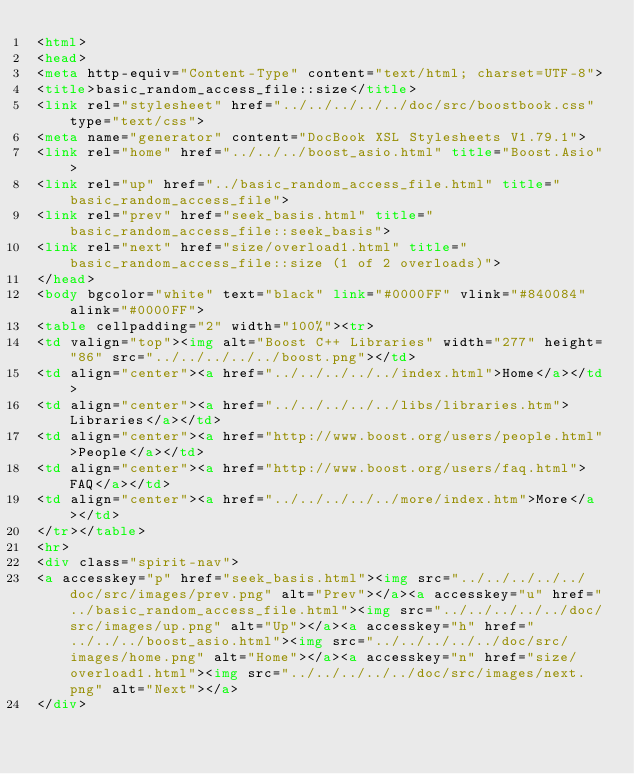<code> <loc_0><loc_0><loc_500><loc_500><_HTML_><html>
<head>
<meta http-equiv="Content-Type" content="text/html; charset=UTF-8">
<title>basic_random_access_file::size</title>
<link rel="stylesheet" href="../../../../../doc/src/boostbook.css" type="text/css">
<meta name="generator" content="DocBook XSL Stylesheets V1.79.1">
<link rel="home" href="../../../boost_asio.html" title="Boost.Asio">
<link rel="up" href="../basic_random_access_file.html" title="basic_random_access_file">
<link rel="prev" href="seek_basis.html" title="basic_random_access_file::seek_basis">
<link rel="next" href="size/overload1.html" title="basic_random_access_file::size (1 of 2 overloads)">
</head>
<body bgcolor="white" text="black" link="#0000FF" vlink="#840084" alink="#0000FF">
<table cellpadding="2" width="100%"><tr>
<td valign="top"><img alt="Boost C++ Libraries" width="277" height="86" src="../../../../../boost.png"></td>
<td align="center"><a href="../../../../../index.html">Home</a></td>
<td align="center"><a href="../../../../../libs/libraries.htm">Libraries</a></td>
<td align="center"><a href="http://www.boost.org/users/people.html">People</a></td>
<td align="center"><a href="http://www.boost.org/users/faq.html">FAQ</a></td>
<td align="center"><a href="../../../../../more/index.htm">More</a></td>
</tr></table>
<hr>
<div class="spirit-nav">
<a accesskey="p" href="seek_basis.html"><img src="../../../../../doc/src/images/prev.png" alt="Prev"></a><a accesskey="u" href="../basic_random_access_file.html"><img src="../../../../../doc/src/images/up.png" alt="Up"></a><a accesskey="h" href="../../../boost_asio.html"><img src="../../../../../doc/src/images/home.png" alt="Home"></a><a accesskey="n" href="size/overload1.html"><img src="../../../../../doc/src/images/next.png" alt="Next"></a>
</div></code> 